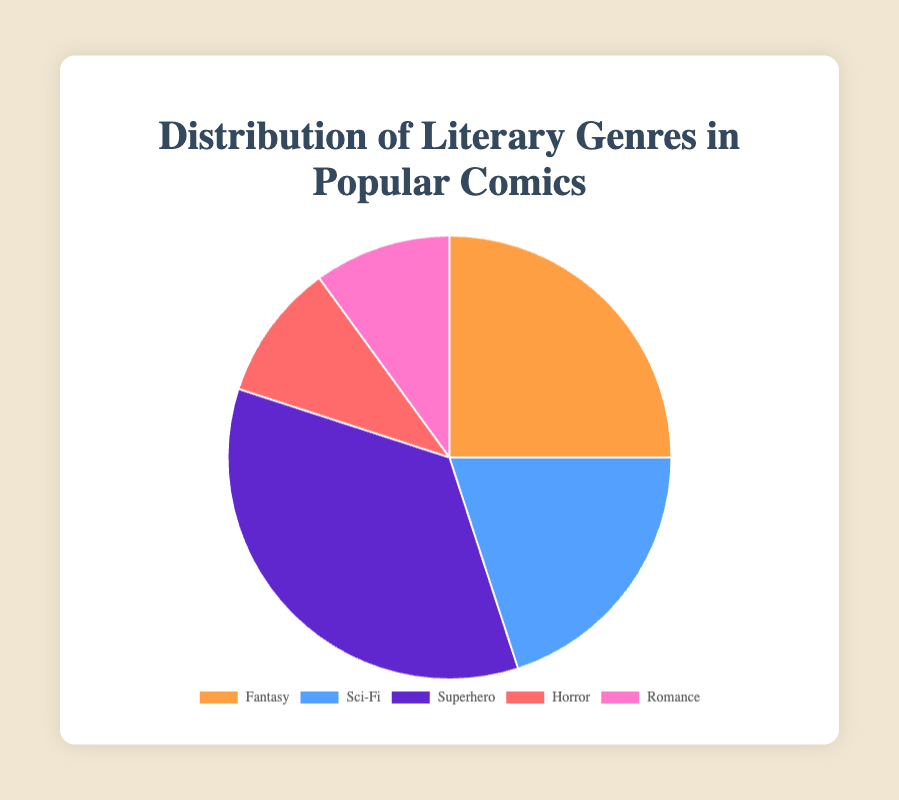What genre has the highest percentage representation in popular comics? The pie chart shows that the Superhero genre has the highest percentage, displayed as the largest section.
Answer: Superhero Which genres have an equal percentage representation? The pie chart displays that both Horror and Romance genres cover the same smallest-sized sections, each at 10%.
Answer: Horror and Romance How much greater is the percentage of Fantasy comics compared to Horror comics? The Fantasy genre shows 25%, while Horror shows 10%. The difference is 25% - 10% = 15%.
Answer: 15% What is the combined percentage of Sci-Fi and Romance genres? The pie chart shows 20% for Sci-Fi and 10% for Romance. Adding them up gives 20% + 10% = 30%.
Answer: 30% If you were to combine Horror and Romance genres into one category, how would their combined percentage compare to the percentage of Sci-Fi comics? Both Horror and Romance have 10% each. Combined, they are 10% + 10% = 20%, which is equal to the percentage of Sci-Fi comics.
Answer: Equal Which genre is depicted using a shade of blue? The pie chart's visual representation shows Sci-Fi in a blue hue.
Answer: Sci-Fi What is the average percentage representation of the Fantasy, Sci-Fi, and Superhero genres? Summing their percentages gives 25% + 20% + 35% = 80%. The average is 80% / 3 = 26.67%.
Answer: 26.67% What is the ratio of Superhero to Romance genre percentages? The Superhero genre is 35%, and Romance is 10%. The ratio is 35 : 10, simplified to 7 : 2.
Answer: 7 : 2 How does the percentage of Superhero comics compare to the combined percentage of Horror and Sci-Fi comics? The Superhero genre has 35%. Horror and Sci-Fi together are 10% + 20% = 30%. Thus, Superhero (35%) is greater than the combined Horror and Sci-Fi (30%).
Answer: Superhero is greater If you reassigned 5% from Fantasy to Romance, how would each genre's new percentage look in comparison to Horror? Fantasy would become 20% (25% - 5%), and Romance would become 15% (10% + 5%). Horror remains at 10%. Fantasy and Romance would both be greater than Horror.
Answer: Both Fantasy and Romance greater 